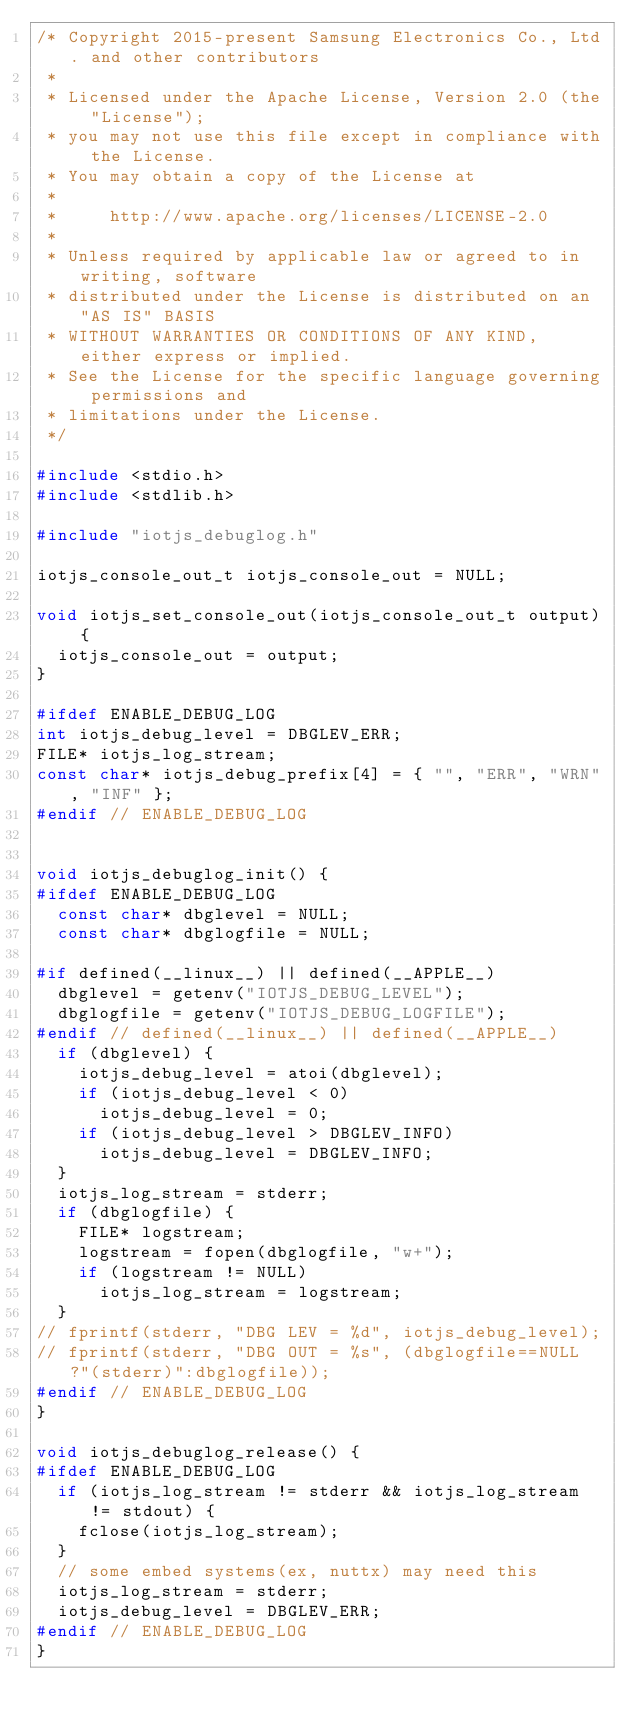<code> <loc_0><loc_0><loc_500><loc_500><_C_>/* Copyright 2015-present Samsung Electronics Co., Ltd. and other contributors
 *
 * Licensed under the Apache License, Version 2.0 (the "License");
 * you may not use this file except in compliance with the License.
 * You may obtain a copy of the License at
 *
 *     http://www.apache.org/licenses/LICENSE-2.0
 *
 * Unless required by applicable law or agreed to in writing, software
 * distributed under the License is distributed on an "AS IS" BASIS
 * WITHOUT WARRANTIES OR CONDITIONS OF ANY KIND, either express or implied.
 * See the License for the specific language governing permissions and
 * limitations under the License.
 */

#include <stdio.h>
#include <stdlib.h>

#include "iotjs_debuglog.h"

iotjs_console_out_t iotjs_console_out = NULL;

void iotjs_set_console_out(iotjs_console_out_t output) {
  iotjs_console_out = output;
}

#ifdef ENABLE_DEBUG_LOG
int iotjs_debug_level = DBGLEV_ERR;
FILE* iotjs_log_stream;
const char* iotjs_debug_prefix[4] = { "", "ERR", "WRN", "INF" };
#endif // ENABLE_DEBUG_LOG


void iotjs_debuglog_init() {
#ifdef ENABLE_DEBUG_LOG
  const char* dbglevel = NULL;
  const char* dbglogfile = NULL;

#if defined(__linux__) || defined(__APPLE__)
  dbglevel = getenv("IOTJS_DEBUG_LEVEL");
  dbglogfile = getenv("IOTJS_DEBUG_LOGFILE");
#endif // defined(__linux__) || defined(__APPLE__)
  if (dbglevel) {
    iotjs_debug_level = atoi(dbglevel);
    if (iotjs_debug_level < 0)
      iotjs_debug_level = 0;
    if (iotjs_debug_level > DBGLEV_INFO)
      iotjs_debug_level = DBGLEV_INFO;
  }
  iotjs_log_stream = stderr;
  if (dbglogfile) {
    FILE* logstream;
    logstream = fopen(dbglogfile, "w+");
    if (logstream != NULL)
      iotjs_log_stream = logstream;
  }
// fprintf(stderr, "DBG LEV = %d", iotjs_debug_level);
// fprintf(stderr, "DBG OUT = %s", (dbglogfile==NULL?"(stderr)":dbglogfile));
#endif // ENABLE_DEBUG_LOG
}

void iotjs_debuglog_release() {
#ifdef ENABLE_DEBUG_LOG
  if (iotjs_log_stream != stderr && iotjs_log_stream != stdout) {
    fclose(iotjs_log_stream);
  }
  // some embed systems(ex, nuttx) may need this
  iotjs_log_stream = stderr;
  iotjs_debug_level = DBGLEV_ERR;
#endif // ENABLE_DEBUG_LOG
}
</code> 